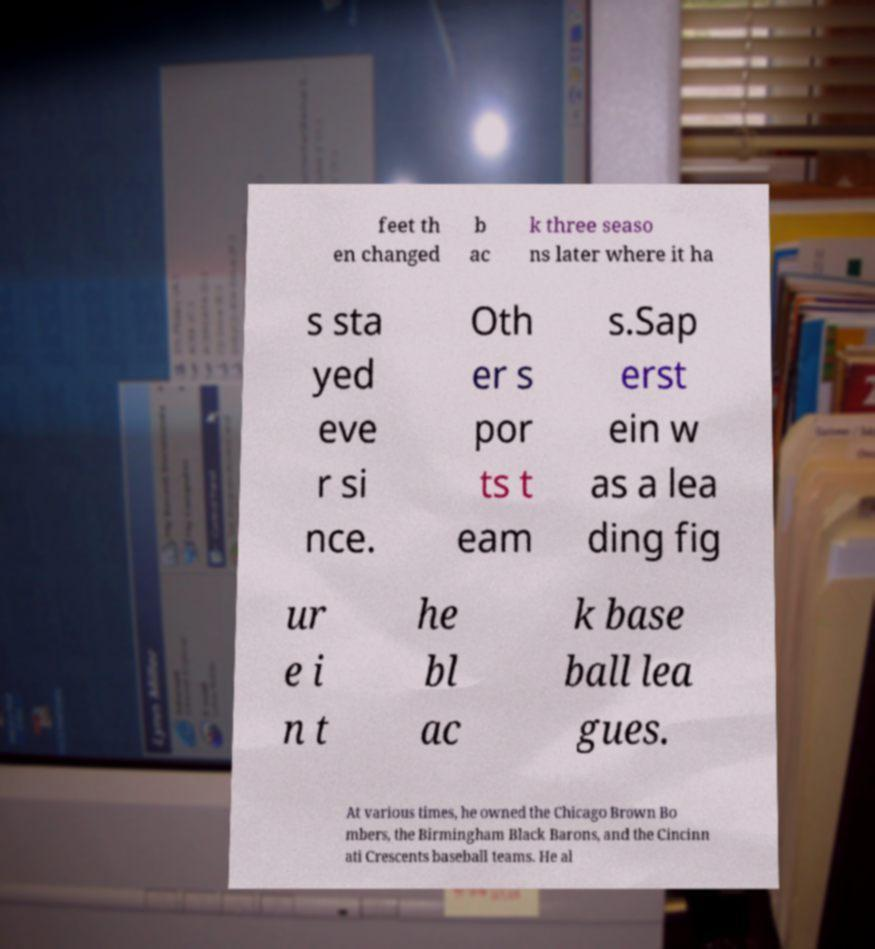Could you extract and type out the text from this image? feet th en changed b ac k three seaso ns later where it ha s sta yed eve r si nce. Oth er s por ts t eam s.Sap erst ein w as a lea ding fig ur e i n t he bl ac k base ball lea gues. At various times, he owned the Chicago Brown Bo mbers, the Birmingham Black Barons, and the Cincinn ati Crescents baseball teams. He al 